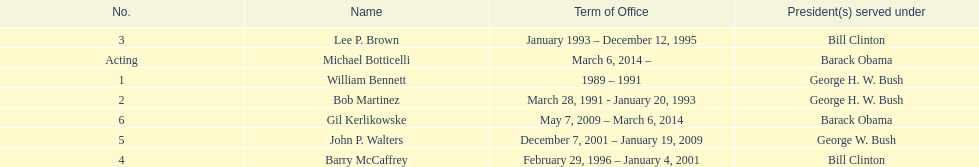What were the number of directors that stayed in office more than three years? 3. 